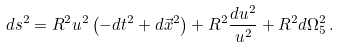Convert formula to latex. <formula><loc_0><loc_0><loc_500><loc_500>d s ^ { 2 } = R ^ { 2 } u ^ { 2 } \left ( - d t ^ { 2 } + d \vec { x } ^ { 2 } \right ) + R ^ { 2 } \frac { d u ^ { 2 } } { u ^ { 2 } } + R ^ { 2 } d \Omega _ { 5 } ^ { 2 } \, .</formula> 